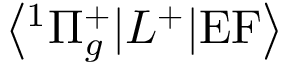Convert formula to latex. <formula><loc_0><loc_0><loc_500><loc_500>\left < ^ { 1 } \Pi _ { g } ^ { + } | L ^ { + } | E F \right ></formula> 